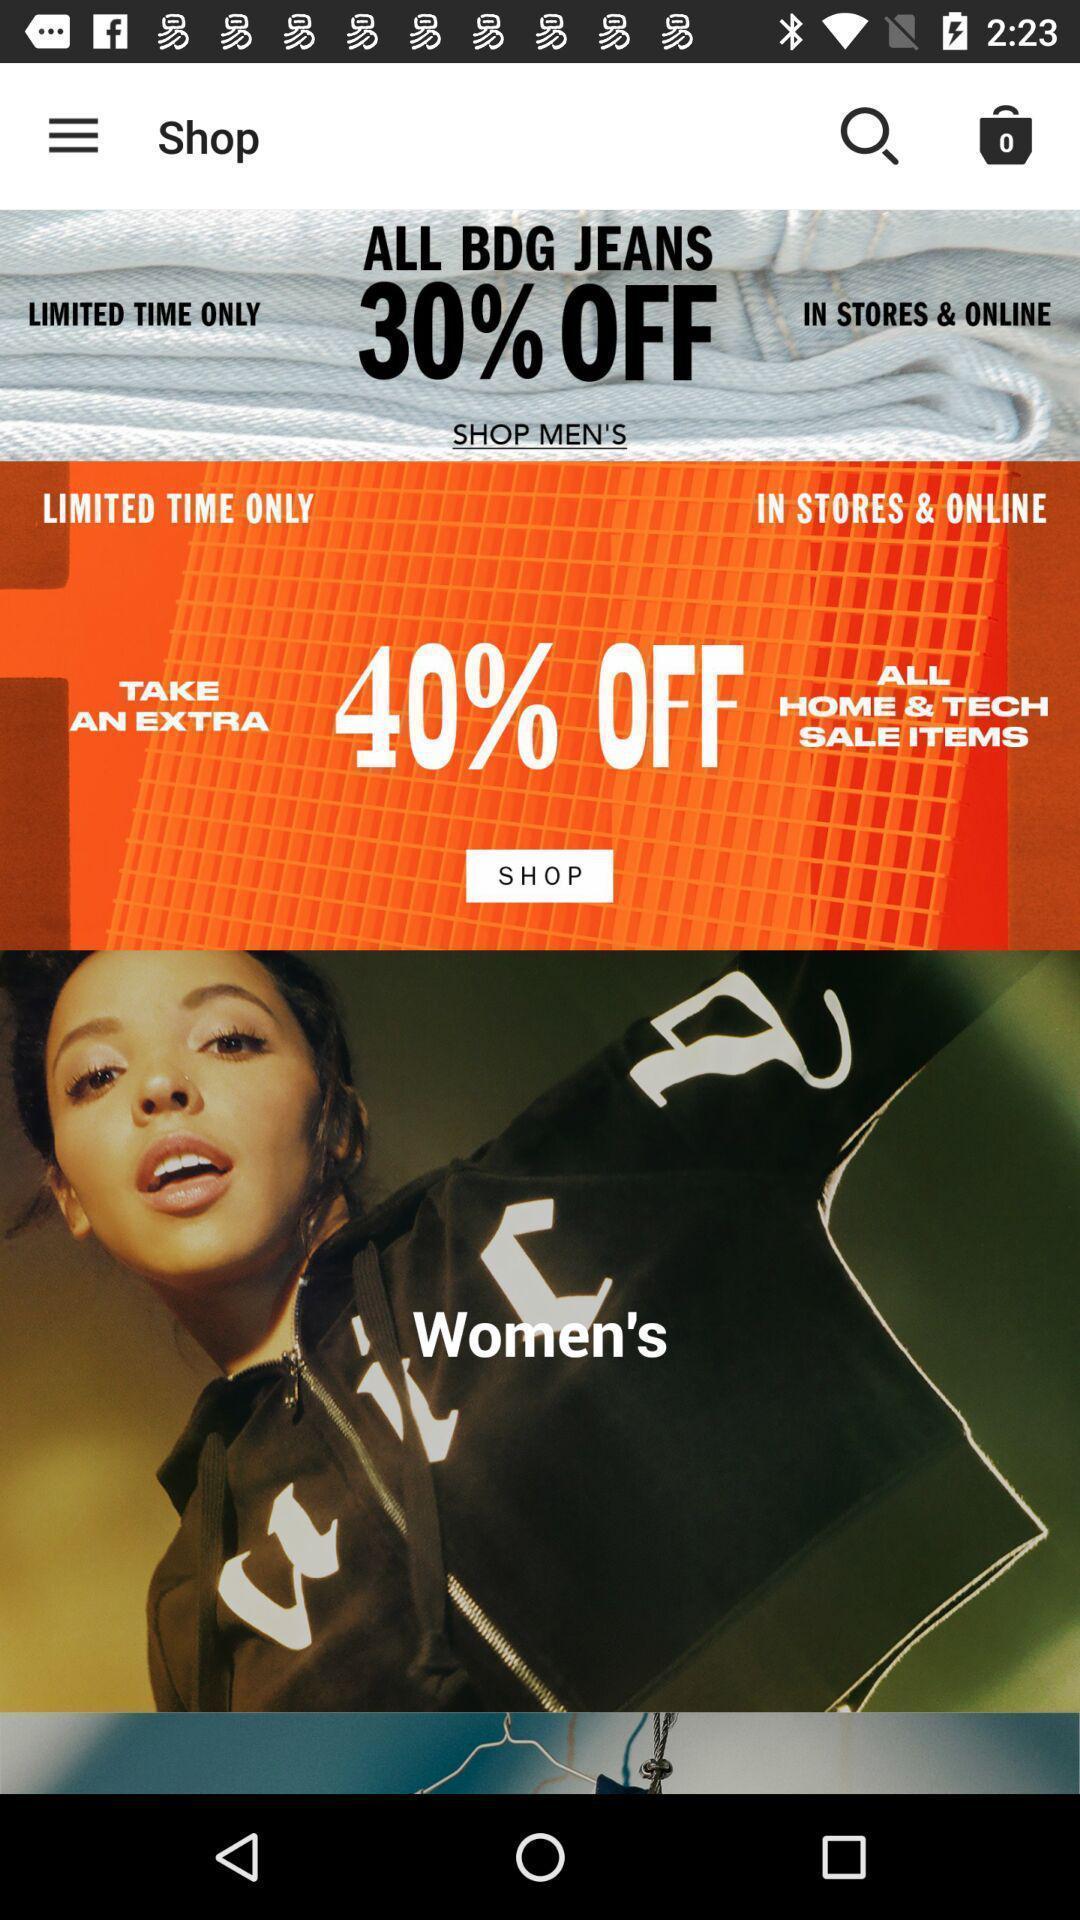Describe the content in this image. Screen page of a shopping application. 